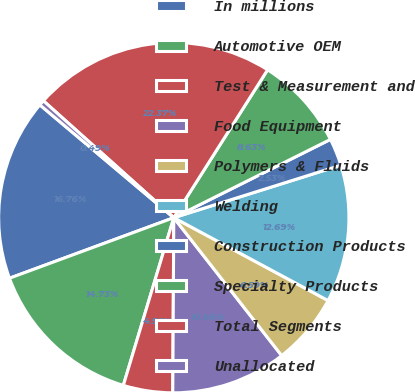<chart> <loc_0><loc_0><loc_500><loc_500><pie_chart><fcel>In millions<fcel>Automotive OEM<fcel>Test & Measurement and<fcel>Food Equipment<fcel>Polymers & Fluids<fcel>Welding<fcel>Construction Products<fcel>Specialty Products<fcel>Total Segments<fcel>Unallocated<nl><fcel>16.76%<fcel>14.73%<fcel>4.56%<fcel>10.66%<fcel>6.59%<fcel>12.69%<fcel>2.53%<fcel>8.63%<fcel>22.37%<fcel>0.49%<nl></chart> 